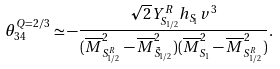<formula> <loc_0><loc_0><loc_500><loc_500>\theta ^ { Q = 2 / 3 } _ { 3 4 } \simeq - \frac { \sqrt { 2 } Y ^ { R } _ { S _ { 1 / 2 } } h _ { S _ { 1 } } v ^ { 3 } } { ( \overline { M } ^ { 2 } _ { S ^ { R } _ { 1 / 2 } } - \overline { M } ^ { 2 } _ { \tilde { S } _ { 1 / 2 } } ) ( \overline { M } ^ { 2 } _ { S _ { 1 } } - \overline { M } ^ { 2 } _ { S ^ { R } _ { 1 / 2 } } ) } .</formula> 